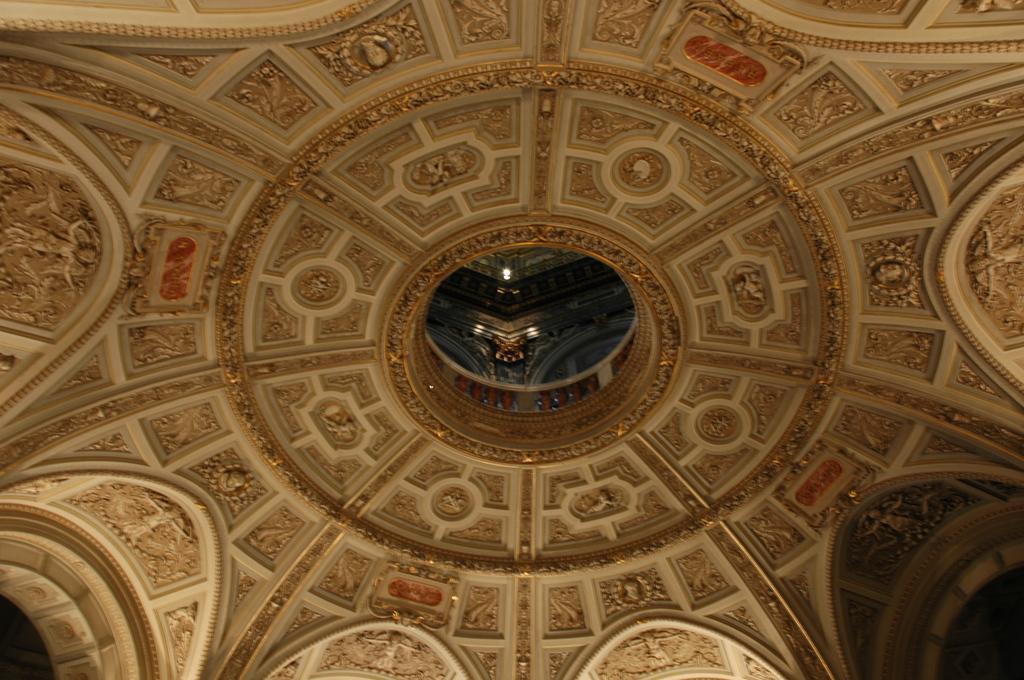Describe this image in one or two sentences. In this image there is a roof with many carvings and sculptures. 